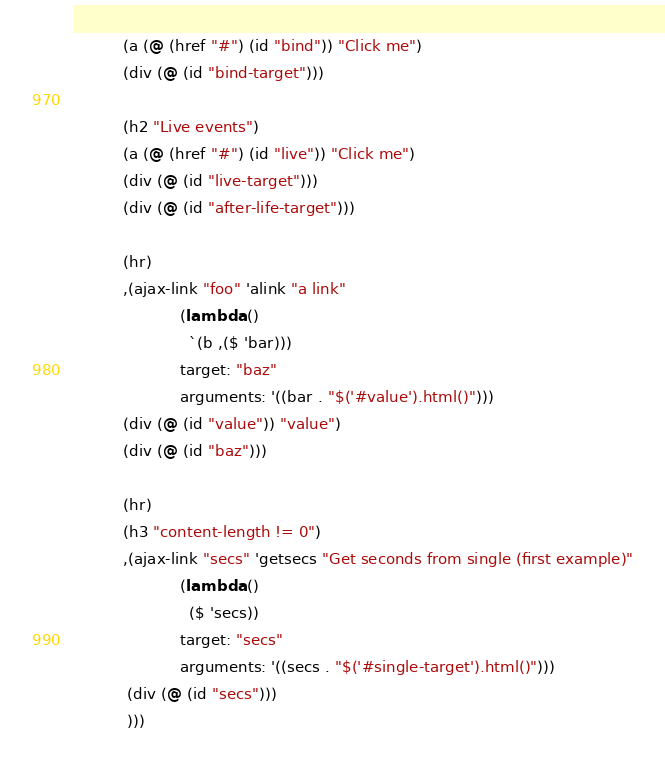Convert code to text. <code><loc_0><loc_0><loc_500><loc_500><_Scheme_>          (a (@ (href "#") (id "bind")) "Click me")
          (div (@ (id "bind-target")))

          (h2 "Live events")
          (a (@ (href "#") (id "live")) "Click me")
          (div (@ (id "live-target")))
          (div (@ (id "after-life-target")))

          (hr)
          ,(ajax-link "foo" 'alink "a link"
                      (lambda ()
                        `(b ,($ 'bar)))
                      target: "baz"
                      arguments: '((bar . "$('#value').html()")))
          (div (@ (id "value")) "value")
          (div (@ (id "baz")))

          (hr)
          (h3 "content-length != 0")
          ,(ajax-link "secs" 'getsecs "Get seconds from single (first example)"
                      (lambda ()
                        ($ 'secs))
                      target: "secs"
                      arguments: '((secs . "$('#single-target').html()")))
           (div (@ (id "secs")))
           )))
</code> 